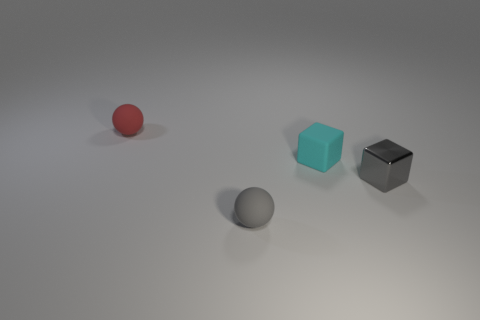Add 4 small gray metallic blocks. How many objects exist? 8 Subtract 0 brown spheres. How many objects are left? 4 Subtract all brown blocks. Subtract all yellow cylinders. How many blocks are left? 2 Subtract all red things. Subtract all small red matte objects. How many objects are left? 2 Add 4 small matte balls. How many small matte balls are left? 6 Add 1 tiny gray metal objects. How many tiny gray metal objects exist? 2 